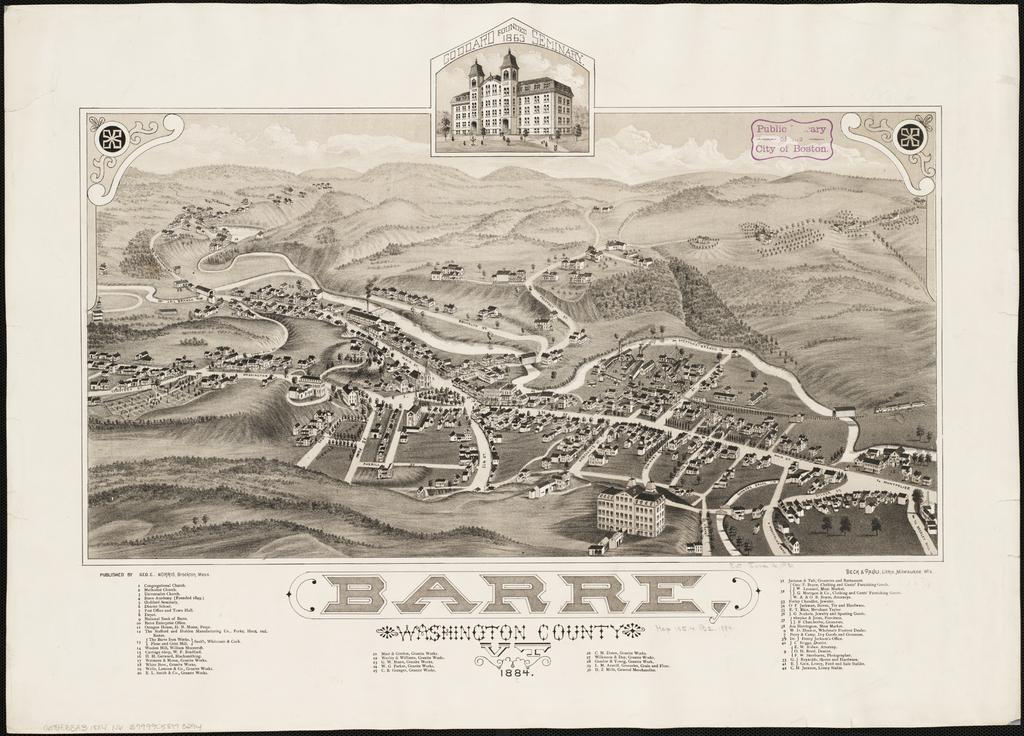<image>
Relay a brief, clear account of the picture shown. the word barre that is on a little map 